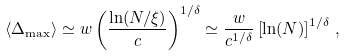<formula> <loc_0><loc_0><loc_500><loc_500>\langle \Delta _ { \max } \rangle \simeq w \left ( \frac { \ln ( N / \xi ) } { c } \right ) ^ { 1 / \delta } \simeq \frac { w } { c ^ { 1 / \delta } } \left [ \ln ( N ) \right ] ^ { 1 / \delta } \, ,</formula> 